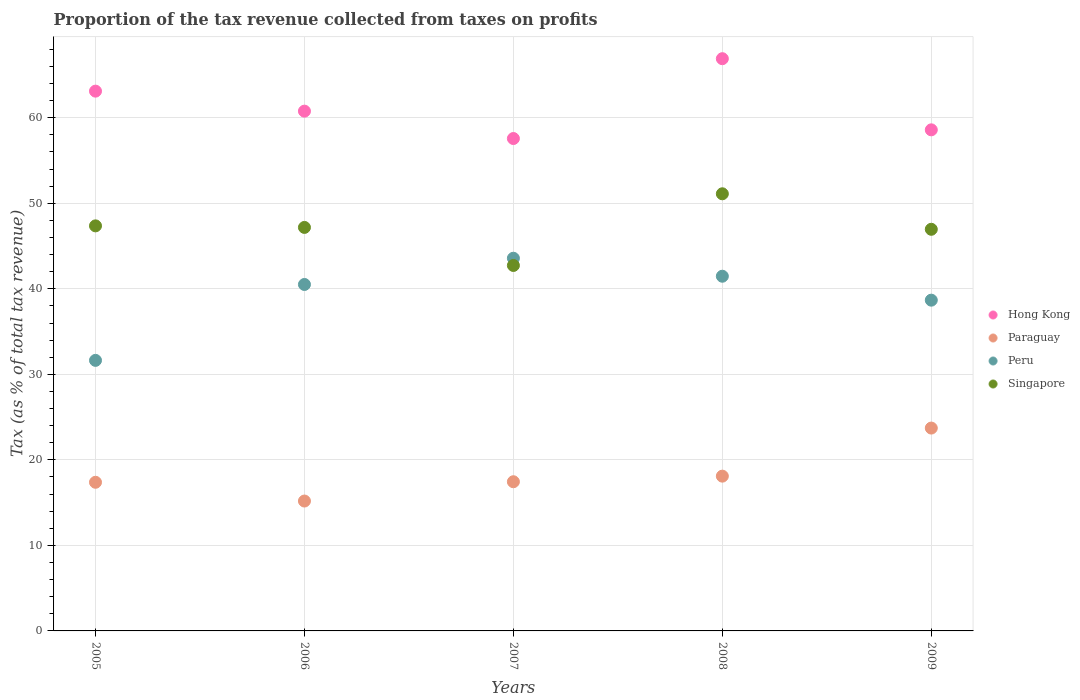How many different coloured dotlines are there?
Ensure brevity in your answer.  4. Is the number of dotlines equal to the number of legend labels?
Offer a very short reply. Yes. What is the proportion of the tax revenue collected in Peru in 2006?
Give a very brief answer. 40.5. Across all years, what is the maximum proportion of the tax revenue collected in Singapore?
Your answer should be very brief. 51.11. Across all years, what is the minimum proportion of the tax revenue collected in Singapore?
Provide a short and direct response. 42.73. In which year was the proportion of the tax revenue collected in Singapore maximum?
Your answer should be very brief. 2008. In which year was the proportion of the tax revenue collected in Peru minimum?
Ensure brevity in your answer.  2005. What is the total proportion of the tax revenue collected in Paraguay in the graph?
Your answer should be very brief. 91.82. What is the difference between the proportion of the tax revenue collected in Hong Kong in 2006 and that in 2007?
Give a very brief answer. 3.2. What is the difference between the proportion of the tax revenue collected in Paraguay in 2006 and the proportion of the tax revenue collected in Peru in 2007?
Your answer should be very brief. -28.39. What is the average proportion of the tax revenue collected in Hong Kong per year?
Your response must be concise. 61.39. In the year 2009, what is the difference between the proportion of the tax revenue collected in Paraguay and proportion of the tax revenue collected in Singapore?
Provide a succinct answer. -23.24. In how many years, is the proportion of the tax revenue collected in Singapore greater than 24 %?
Your response must be concise. 5. What is the ratio of the proportion of the tax revenue collected in Peru in 2005 to that in 2007?
Your answer should be very brief. 0.73. Is the proportion of the tax revenue collected in Paraguay in 2008 less than that in 2009?
Make the answer very short. Yes. Is the difference between the proportion of the tax revenue collected in Paraguay in 2008 and 2009 greater than the difference between the proportion of the tax revenue collected in Singapore in 2008 and 2009?
Keep it short and to the point. No. What is the difference between the highest and the second highest proportion of the tax revenue collected in Peru?
Provide a short and direct response. 2.1. What is the difference between the highest and the lowest proportion of the tax revenue collected in Paraguay?
Offer a terse response. 8.53. In how many years, is the proportion of the tax revenue collected in Peru greater than the average proportion of the tax revenue collected in Peru taken over all years?
Keep it short and to the point. 3. Is the sum of the proportion of the tax revenue collected in Paraguay in 2006 and 2009 greater than the maximum proportion of the tax revenue collected in Hong Kong across all years?
Make the answer very short. No. Is it the case that in every year, the sum of the proportion of the tax revenue collected in Peru and proportion of the tax revenue collected in Hong Kong  is greater than the proportion of the tax revenue collected in Paraguay?
Provide a succinct answer. Yes. Does the proportion of the tax revenue collected in Paraguay monotonically increase over the years?
Keep it short and to the point. No. How many dotlines are there?
Your answer should be very brief. 4. What is the difference between two consecutive major ticks on the Y-axis?
Make the answer very short. 10. Are the values on the major ticks of Y-axis written in scientific E-notation?
Offer a terse response. No. Where does the legend appear in the graph?
Your answer should be very brief. Center right. How are the legend labels stacked?
Make the answer very short. Vertical. What is the title of the graph?
Give a very brief answer. Proportion of the tax revenue collected from taxes on profits. What is the label or title of the X-axis?
Keep it short and to the point. Years. What is the label or title of the Y-axis?
Keep it short and to the point. Tax (as % of total tax revenue). What is the Tax (as % of total tax revenue) in Hong Kong in 2005?
Ensure brevity in your answer.  63.11. What is the Tax (as % of total tax revenue) in Paraguay in 2005?
Your response must be concise. 17.38. What is the Tax (as % of total tax revenue) of Peru in 2005?
Your response must be concise. 31.63. What is the Tax (as % of total tax revenue) of Singapore in 2005?
Your answer should be very brief. 47.36. What is the Tax (as % of total tax revenue) in Hong Kong in 2006?
Offer a terse response. 60.77. What is the Tax (as % of total tax revenue) of Paraguay in 2006?
Offer a terse response. 15.19. What is the Tax (as % of total tax revenue) of Peru in 2006?
Offer a very short reply. 40.5. What is the Tax (as % of total tax revenue) in Singapore in 2006?
Offer a very short reply. 47.18. What is the Tax (as % of total tax revenue) of Hong Kong in 2007?
Offer a very short reply. 57.57. What is the Tax (as % of total tax revenue) of Paraguay in 2007?
Give a very brief answer. 17.44. What is the Tax (as % of total tax revenue) in Peru in 2007?
Offer a terse response. 43.57. What is the Tax (as % of total tax revenue) in Singapore in 2007?
Provide a succinct answer. 42.73. What is the Tax (as % of total tax revenue) in Hong Kong in 2008?
Provide a succinct answer. 66.9. What is the Tax (as % of total tax revenue) of Paraguay in 2008?
Ensure brevity in your answer.  18.1. What is the Tax (as % of total tax revenue) of Peru in 2008?
Your response must be concise. 41.47. What is the Tax (as % of total tax revenue) of Singapore in 2008?
Provide a succinct answer. 51.11. What is the Tax (as % of total tax revenue) in Hong Kong in 2009?
Offer a very short reply. 58.59. What is the Tax (as % of total tax revenue) in Paraguay in 2009?
Offer a very short reply. 23.72. What is the Tax (as % of total tax revenue) in Peru in 2009?
Make the answer very short. 38.67. What is the Tax (as % of total tax revenue) in Singapore in 2009?
Ensure brevity in your answer.  46.96. Across all years, what is the maximum Tax (as % of total tax revenue) of Hong Kong?
Your answer should be compact. 66.9. Across all years, what is the maximum Tax (as % of total tax revenue) of Paraguay?
Offer a terse response. 23.72. Across all years, what is the maximum Tax (as % of total tax revenue) in Peru?
Ensure brevity in your answer.  43.57. Across all years, what is the maximum Tax (as % of total tax revenue) in Singapore?
Keep it short and to the point. 51.11. Across all years, what is the minimum Tax (as % of total tax revenue) of Hong Kong?
Offer a terse response. 57.57. Across all years, what is the minimum Tax (as % of total tax revenue) of Paraguay?
Your response must be concise. 15.19. Across all years, what is the minimum Tax (as % of total tax revenue) in Peru?
Provide a short and direct response. 31.63. Across all years, what is the minimum Tax (as % of total tax revenue) of Singapore?
Your response must be concise. 42.73. What is the total Tax (as % of total tax revenue) of Hong Kong in the graph?
Keep it short and to the point. 306.94. What is the total Tax (as % of total tax revenue) in Paraguay in the graph?
Your answer should be compact. 91.82. What is the total Tax (as % of total tax revenue) in Peru in the graph?
Ensure brevity in your answer.  195.85. What is the total Tax (as % of total tax revenue) in Singapore in the graph?
Your answer should be compact. 235.33. What is the difference between the Tax (as % of total tax revenue) of Hong Kong in 2005 and that in 2006?
Make the answer very short. 2.34. What is the difference between the Tax (as % of total tax revenue) in Paraguay in 2005 and that in 2006?
Ensure brevity in your answer.  2.19. What is the difference between the Tax (as % of total tax revenue) in Peru in 2005 and that in 2006?
Your response must be concise. -8.87. What is the difference between the Tax (as % of total tax revenue) in Singapore in 2005 and that in 2006?
Provide a succinct answer. 0.18. What is the difference between the Tax (as % of total tax revenue) of Hong Kong in 2005 and that in 2007?
Provide a short and direct response. 5.54. What is the difference between the Tax (as % of total tax revenue) of Paraguay in 2005 and that in 2007?
Offer a very short reply. -0.06. What is the difference between the Tax (as % of total tax revenue) in Peru in 2005 and that in 2007?
Offer a very short reply. -11.94. What is the difference between the Tax (as % of total tax revenue) of Singapore in 2005 and that in 2007?
Provide a short and direct response. 4.63. What is the difference between the Tax (as % of total tax revenue) in Hong Kong in 2005 and that in 2008?
Your answer should be compact. -3.79. What is the difference between the Tax (as % of total tax revenue) of Paraguay in 2005 and that in 2008?
Make the answer very short. -0.72. What is the difference between the Tax (as % of total tax revenue) of Peru in 2005 and that in 2008?
Offer a very short reply. -9.84. What is the difference between the Tax (as % of total tax revenue) in Singapore in 2005 and that in 2008?
Make the answer very short. -3.75. What is the difference between the Tax (as % of total tax revenue) in Hong Kong in 2005 and that in 2009?
Your answer should be very brief. 4.52. What is the difference between the Tax (as % of total tax revenue) of Paraguay in 2005 and that in 2009?
Keep it short and to the point. -6.34. What is the difference between the Tax (as % of total tax revenue) in Peru in 2005 and that in 2009?
Your answer should be compact. -7.04. What is the difference between the Tax (as % of total tax revenue) of Singapore in 2005 and that in 2009?
Your answer should be compact. 0.4. What is the difference between the Tax (as % of total tax revenue) in Hong Kong in 2006 and that in 2007?
Your response must be concise. 3.2. What is the difference between the Tax (as % of total tax revenue) in Paraguay in 2006 and that in 2007?
Your response must be concise. -2.26. What is the difference between the Tax (as % of total tax revenue) of Peru in 2006 and that in 2007?
Ensure brevity in your answer.  -3.07. What is the difference between the Tax (as % of total tax revenue) of Singapore in 2006 and that in 2007?
Keep it short and to the point. 4.45. What is the difference between the Tax (as % of total tax revenue) in Hong Kong in 2006 and that in 2008?
Your response must be concise. -6.13. What is the difference between the Tax (as % of total tax revenue) of Paraguay in 2006 and that in 2008?
Your answer should be very brief. -2.91. What is the difference between the Tax (as % of total tax revenue) in Peru in 2006 and that in 2008?
Offer a very short reply. -0.96. What is the difference between the Tax (as % of total tax revenue) of Singapore in 2006 and that in 2008?
Offer a terse response. -3.93. What is the difference between the Tax (as % of total tax revenue) in Hong Kong in 2006 and that in 2009?
Ensure brevity in your answer.  2.18. What is the difference between the Tax (as % of total tax revenue) in Paraguay in 2006 and that in 2009?
Make the answer very short. -8.53. What is the difference between the Tax (as % of total tax revenue) in Peru in 2006 and that in 2009?
Give a very brief answer. 1.83. What is the difference between the Tax (as % of total tax revenue) in Singapore in 2006 and that in 2009?
Your answer should be compact. 0.22. What is the difference between the Tax (as % of total tax revenue) in Hong Kong in 2007 and that in 2008?
Keep it short and to the point. -9.33. What is the difference between the Tax (as % of total tax revenue) in Paraguay in 2007 and that in 2008?
Your answer should be very brief. -0.65. What is the difference between the Tax (as % of total tax revenue) in Peru in 2007 and that in 2008?
Ensure brevity in your answer.  2.1. What is the difference between the Tax (as % of total tax revenue) of Singapore in 2007 and that in 2008?
Offer a terse response. -8.38. What is the difference between the Tax (as % of total tax revenue) in Hong Kong in 2007 and that in 2009?
Provide a succinct answer. -1.02. What is the difference between the Tax (as % of total tax revenue) in Paraguay in 2007 and that in 2009?
Ensure brevity in your answer.  -6.28. What is the difference between the Tax (as % of total tax revenue) of Peru in 2007 and that in 2009?
Your response must be concise. 4.9. What is the difference between the Tax (as % of total tax revenue) in Singapore in 2007 and that in 2009?
Your response must be concise. -4.23. What is the difference between the Tax (as % of total tax revenue) in Hong Kong in 2008 and that in 2009?
Ensure brevity in your answer.  8.32. What is the difference between the Tax (as % of total tax revenue) in Paraguay in 2008 and that in 2009?
Offer a very short reply. -5.62. What is the difference between the Tax (as % of total tax revenue) in Peru in 2008 and that in 2009?
Provide a short and direct response. 2.8. What is the difference between the Tax (as % of total tax revenue) of Singapore in 2008 and that in 2009?
Give a very brief answer. 4.15. What is the difference between the Tax (as % of total tax revenue) of Hong Kong in 2005 and the Tax (as % of total tax revenue) of Paraguay in 2006?
Your answer should be very brief. 47.92. What is the difference between the Tax (as % of total tax revenue) of Hong Kong in 2005 and the Tax (as % of total tax revenue) of Peru in 2006?
Your answer should be compact. 22.6. What is the difference between the Tax (as % of total tax revenue) in Hong Kong in 2005 and the Tax (as % of total tax revenue) in Singapore in 2006?
Provide a short and direct response. 15.93. What is the difference between the Tax (as % of total tax revenue) in Paraguay in 2005 and the Tax (as % of total tax revenue) in Peru in 2006?
Provide a short and direct response. -23.13. What is the difference between the Tax (as % of total tax revenue) of Paraguay in 2005 and the Tax (as % of total tax revenue) of Singapore in 2006?
Offer a very short reply. -29.8. What is the difference between the Tax (as % of total tax revenue) of Peru in 2005 and the Tax (as % of total tax revenue) of Singapore in 2006?
Your response must be concise. -15.54. What is the difference between the Tax (as % of total tax revenue) in Hong Kong in 2005 and the Tax (as % of total tax revenue) in Paraguay in 2007?
Keep it short and to the point. 45.67. What is the difference between the Tax (as % of total tax revenue) in Hong Kong in 2005 and the Tax (as % of total tax revenue) in Peru in 2007?
Provide a short and direct response. 19.54. What is the difference between the Tax (as % of total tax revenue) of Hong Kong in 2005 and the Tax (as % of total tax revenue) of Singapore in 2007?
Provide a succinct answer. 20.38. What is the difference between the Tax (as % of total tax revenue) of Paraguay in 2005 and the Tax (as % of total tax revenue) of Peru in 2007?
Give a very brief answer. -26.19. What is the difference between the Tax (as % of total tax revenue) in Paraguay in 2005 and the Tax (as % of total tax revenue) in Singapore in 2007?
Your answer should be very brief. -25.35. What is the difference between the Tax (as % of total tax revenue) in Peru in 2005 and the Tax (as % of total tax revenue) in Singapore in 2007?
Offer a terse response. -11.1. What is the difference between the Tax (as % of total tax revenue) of Hong Kong in 2005 and the Tax (as % of total tax revenue) of Paraguay in 2008?
Your answer should be very brief. 45.01. What is the difference between the Tax (as % of total tax revenue) in Hong Kong in 2005 and the Tax (as % of total tax revenue) in Peru in 2008?
Make the answer very short. 21.64. What is the difference between the Tax (as % of total tax revenue) in Hong Kong in 2005 and the Tax (as % of total tax revenue) in Singapore in 2008?
Provide a succinct answer. 12. What is the difference between the Tax (as % of total tax revenue) of Paraguay in 2005 and the Tax (as % of total tax revenue) of Peru in 2008?
Keep it short and to the point. -24.09. What is the difference between the Tax (as % of total tax revenue) in Paraguay in 2005 and the Tax (as % of total tax revenue) in Singapore in 2008?
Make the answer very short. -33.73. What is the difference between the Tax (as % of total tax revenue) of Peru in 2005 and the Tax (as % of total tax revenue) of Singapore in 2008?
Your answer should be compact. -19.48. What is the difference between the Tax (as % of total tax revenue) of Hong Kong in 2005 and the Tax (as % of total tax revenue) of Paraguay in 2009?
Provide a succinct answer. 39.39. What is the difference between the Tax (as % of total tax revenue) in Hong Kong in 2005 and the Tax (as % of total tax revenue) in Peru in 2009?
Make the answer very short. 24.44. What is the difference between the Tax (as % of total tax revenue) of Hong Kong in 2005 and the Tax (as % of total tax revenue) of Singapore in 2009?
Keep it short and to the point. 16.15. What is the difference between the Tax (as % of total tax revenue) in Paraguay in 2005 and the Tax (as % of total tax revenue) in Peru in 2009?
Provide a succinct answer. -21.29. What is the difference between the Tax (as % of total tax revenue) in Paraguay in 2005 and the Tax (as % of total tax revenue) in Singapore in 2009?
Ensure brevity in your answer.  -29.58. What is the difference between the Tax (as % of total tax revenue) in Peru in 2005 and the Tax (as % of total tax revenue) in Singapore in 2009?
Provide a succinct answer. -15.33. What is the difference between the Tax (as % of total tax revenue) of Hong Kong in 2006 and the Tax (as % of total tax revenue) of Paraguay in 2007?
Provide a short and direct response. 43.33. What is the difference between the Tax (as % of total tax revenue) in Hong Kong in 2006 and the Tax (as % of total tax revenue) in Peru in 2007?
Give a very brief answer. 17.2. What is the difference between the Tax (as % of total tax revenue) in Hong Kong in 2006 and the Tax (as % of total tax revenue) in Singapore in 2007?
Give a very brief answer. 18.04. What is the difference between the Tax (as % of total tax revenue) in Paraguay in 2006 and the Tax (as % of total tax revenue) in Peru in 2007?
Provide a short and direct response. -28.39. What is the difference between the Tax (as % of total tax revenue) in Paraguay in 2006 and the Tax (as % of total tax revenue) in Singapore in 2007?
Make the answer very short. -27.54. What is the difference between the Tax (as % of total tax revenue) of Peru in 2006 and the Tax (as % of total tax revenue) of Singapore in 2007?
Keep it short and to the point. -2.22. What is the difference between the Tax (as % of total tax revenue) in Hong Kong in 2006 and the Tax (as % of total tax revenue) in Paraguay in 2008?
Your answer should be very brief. 42.67. What is the difference between the Tax (as % of total tax revenue) of Hong Kong in 2006 and the Tax (as % of total tax revenue) of Peru in 2008?
Keep it short and to the point. 19.3. What is the difference between the Tax (as % of total tax revenue) in Hong Kong in 2006 and the Tax (as % of total tax revenue) in Singapore in 2008?
Provide a short and direct response. 9.66. What is the difference between the Tax (as % of total tax revenue) in Paraguay in 2006 and the Tax (as % of total tax revenue) in Peru in 2008?
Your response must be concise. -26.28. What is the difference between the Tax (as % of total tax revenue) in Paraguay in 2006 and the Tax (as % of total tax revenue) in Singapore in 2008?
Make the answer very short. -35.92. What is the difference between the Tax (as % of total tax revenue) of Peru in 2006 and the Tax (as % of total tax revenue) of Singapore in 2008?
Make the answer very short. -10.6. What is the difference between the Tax (as % of total tax revenue) in Hong Kong in 2006 and the Tax (as % of total tax revenue) in Paraguay in 2009?
Provide a short and direct response. 37.05. What is the difference between the Tax (as % of total tax revenue) in Hong Kong in 2006 and the Tax (as % of total tax revenue) in Peru in 2009?
Offer a terse response. 22.1. What is the difference between the Tax (as % of total tax revenue) in Hong Kong in 2006 and the Tax (as % of total tax revenue) in Singapore in 2009?
Offer a terse response. 13.81. What is the difference between the Tax (as % of total tax revenue) of Paraguay in 2006 and the Tax (as % of total tax revenue) of Peru in 2009?
Provide a succinct answer. -23.49. What is the difference between the Tax (as % of total tax revenue) of Paraguay in 2006 and the Tax (as % of total tax revenue) of Singapore in 2009?
Your response must be concise. -31.77. What is the difference between the Tax (as % of total tax revenue) in Peru in 2006 and the Tax (as % of total tax revenue) in Singapore in 2009?
Give a very brief answer. -6.45. What is the difference between the Tax (as % of total tax revenue) of Hong Kong in 2007 and the Tax (as % of total tax revenue) of Paraguay in 2008?
Make the answer very short. 39.47. What is the difference between the Tax (as % of total tax revenue) of Hong Kong in 2007 and the Tax (as % of total tax revenue) of Peru in 2008?
Ensure brevity in your answer.  16.1. What is the difference between the Tax (as % of total tax revenue) in Hong Kong in 2007 and the Tax (as % of total tax revenue) in Singapore in 2008?
Your answer should be compact. 6.46. What is the difference between the Tax (as % of total tax revenue) in Paraguay in 2007 and the Tax (as % of total tax revenue) in Peru in 2008?
Your response must be concise. -24.03. What is the difference between the Tax (as % of total tax revenue) in Paraguay in 2007 and the Tax (as % of total tax revenue) in Singapore in 2008?
Keep it short and to the point. -33.67. What is the difference between the Tax (as % of total tax revenue) in Peru in 2007 and the Tax (as % of total tax revenue) in Singapore in 2008?
Your answer should be very brief. -7.53. What is the difference between the Tax (as % of total tax revenue) of Hong Kong in 2007 and the Tax (as % of total tax revenue) of Paraguay in 2009?
Your response must be concise. 33.85. What is the difference between the Tax (as % of total tax revenue) in Hong Kong in 2007 and the Tax (as % of total tax revenue) in Peru in 2009?
Your response must be concise. 18.9. What is the difference between the Tax (as % of total tax revenue) in Hong Kong in 2007 and the Tax (as % of total tax revenue) in Singapore in 2009?
Provide a succinct answer. 10.61. What is the difference between the Tax (as % of total tax revenue) in Paraguay in 2007 and the Tax (as % of total tax revenue) in Peru in 2009?
Your response must be concise. -21.23. What is the difference between the Tax (as % of total tax revenue) of Paraguay in 2007 and the Tax (as % of total tax revenue) of Singapore in 2009?
Offer a terse response. -29.52. What is the difference between the Tax (as % of total tax revenue) in Peru in 2007 and the Tax (as % of total tax revenue) in Singapore in 2009?
Make the answer very short. -3.38. What is the difference between the Tax (as % of total tax revenue) of Hong Kong in 2008 and the Tax (as % of total tax revenue) of Paraguay in 2009?
Your response must be concise. 43.19. What is the difference between the Tax (as % of total tax revenue) of Hong Kong in 2008 and the Tax (as % of total tax revenue) of Peru in 2009?
Offer a very short reply. 28.23. What is the difference between the Tax (as % of total tax revenue) of Hong Kong in 2008 and the Tax (as % of total tax revenue) of Singapore in 2009?
Keep it short and to the point. 19.95. What is the difference between the Tax (as % of total tax revenue) in Paraguay in 2008 and the Tax (as % of total tax revenue) in Peru in 2009?
Provide a short and direct response. -20.57. What is the difference between the Tax (as % of total tax revenue) of Paraguay in 2008 and the Tax (as % of total tax revenue) of Singapore in 2009?
Give a very brief answer. -28.86. What is the difference between the Tax (as % of total tax revenue) in Peru in 2008 and the Tax (as % of total tax revenue) in Singapore in 2009?
Give a very brief answer. -5.49. What is the average Tax (as % of total tax revenue) of Hong Kong per year?
Offer a terse response. 61.39. What is the average Tax (as % of total tax revenue) in Paraguay per year?
Provide a succinct answer. 18.36. What is the average Tax (as % of total tax revenue) of Peru per year?
Ensure brevity in your answer.  39.17. What is the average Tax (as % of total tax revenue) in Singapore per year?
Your answer should be very brief. 47.07. In the year 2005, what is the difference between the Tax (as % of total tax revenue) of Hong Kong and Tax (as % of total tax revenue) of Paraguay?
Give a very brief answer. 45.73. In the year 2005, what is the difference between the Tax (as % of total tax revenue) in Hong Kong and Tax (as % of total tax revenue) in Peru?
Give a very brief answer. 31.48. In the year 2005, what is the difference between the Tax (as % of total tax revenue) in Hong Kong and Tax (as % of total tax revenue) in Singapore?
Ensure brevity in your answer.  15.75. In the year 2005, what is the difference between the Tax (as % of total tax revenue) of Paraguay and Tax (as % of total tax revenue) of Peru?
Provide a succinct answer. -14.25. In the year 2005, what is the difference between the Tax (as % of total tax revenue) in Paraguay and Tax (as % of total tax revenue) in Singapore?
Your response must be concise. -29.98. In the year 2005, what is the difference between the Tax (as % of total tax revenue) in Peru and Tax (as % of total tax revenue) in Singapore?
Offer a very short reply. -15.73. In the year 2006, what is the difference between the Tax (as % of total tax revenue) in Hong Kong and Tax (as % of total tax revenue) in Paraguay?
Your response must be concise. 45.58. In the year 2006, what is the difference between the Tax (as % of total tax revenue) of Hong Kong and Tax (as % of total tax revenue) of Peru?
Make the answer very short. 20.27. In the year 2006, what is the difference between the Tax (as % of total tax revenue) in Hong Kong and Tax (as % of total tax revenue) in Singapore?
Give a very brief answer. 13.59. In the year 2006, what is the difference between the Tax (as % of total tax revenue) of Paraguay and Tax (as % of total tax revenue) of Peru?
Provide a succinct answer. -25.32. In the year 2006, what is the difference between the Tax (as % of total tax revenue) in Paraguay and Tax (as % of total tax revenue) in Singapore?
Make the answer very short. -31.99. In the year 2006, what is the difference between the Tax (as % of total tax revenue) of Peru and Tax (as % of total tax revenue) of Singapore?
Offer a very short reply. -6.67. In the year 2007, what is the difference between the Tax (as % of total tax revenue) of Hong Kong and Tax (as % of total tax revenue) of Paraguay?
Ensure brevity in your answer.  40.13. In the year 2007, what is the difference between the Tax (as % of total tax revenue) of Hong Kong and Tax (as % of total tax revenue) of Peru?
Your response must be concise. 14. In the year 2007, what is the difference between the Tax (as % of total tax revenue) of Hong Kong and Tax (as % of total tax revenue) of Singapore?
Give a very brief answer. 14.84. In the year 2007, what is the difference between the Tax (as % of total tax revenue) in Paraguay and Tax (as % of total tax revenue) in Peru?
Make the answer very short. -26.13. In the year 2007, what is the difference between the Tax (as % of total tax revenue) in Paraguay and Tax (as % of total tax revenue) in Singapore?
Provide a succinct answer. -25.29. In the year 2007, what is the difference between the Tax (as % of total tax revenue) in Peru and Tax (as % of total tax revenue) in Singapore?
Keep it short and to the point. 0.85. In the year 2008, what is the difference between the Tax (as % of total tax revenue) in Hong Kong and Tax (as % of total tax revenue) in Paraguay?
Ensure brevity in your answer.  48.81. In the year 2008, what is the difference between the Tax (as % of total tax revenue) of Hong Kong and Tax (as % of total tax revenue) of Peru?
Ensure brevity in your answer.  25.43. In the year 2008, what is the difference between the Tax (as % of total tax revenue) in Hong Kong and Tax (as % of total tax revenue) in Singapore?
Offer a terse response. 15.8. In the year 2008, what is the difference between the Tax (as % of total tax revenue) of Paraguay and Tax (as % of total tax revenue) of Peru?
Your answer should be compact. -23.37. In the year 2008, what is the difference between the Tax (as % of total tax revenue) of Paraguay and Tax (as % of total tax revenue) of Singapore?
Your answer should be compact. -33.01. In the year 2008, what is the difference between the Tax (as % of total tax revenue) in Peru and Tax (as % of total tax revenue) in Singapore?
Your response must be concise. -9.64. In the year 2009, what is the difference between the Tax (as % of total tax revenue) in Hong Kong and Tax (as % of total tax revenue) in Paraguay?
Offer a terse response. 34.87. In the year 2009, what is the difference between the Tax (as % of total tax revenue) in Hong Kong and Tax (as % of total tax revenue) in Peru?
Ensure brevity in your answer.  19.91. In the year 2009, what is the difference between the Tax (as % of total tax revenue) in Hong Kong and Tax (as % of total tax revenue) in Singapore?
Provide a short and direct response. 11.63. In the year 2009, what is the difference between the Tax (as % of total tax revenue) of Paraguay and Tax (as % of total tax revenue) of Peru?
Give a very brief answer. -14.95. In the year 2009, what is the difference between the Tax (as % of total tax revenue) in Paraguay and Tax (as % of total tax revenue) in Singapore?
Ensure brevity in your answer.  -23.24. In the year 2009, what is the difference between the Tax (as % of total tax revenue) in Peru and Tax (as % of total tax revenue) in Singapore?
Your answer should be very brief. -8.29. What is the ratio of the Tax (as % of total tax revenue) of Hong Kong in 2005 to that in 2006?
Your answer should be very brief. 1.04. What is the ratio of the Tax (as % of total tax revenue) of Paraguay in 2005 to that in 2006?
Give a very brief answer. 1.14. What is the ratio of the Tax (as % of total tax revenue) in Peru in 2005 to that in 2006?
Provide a short and direct response. 0.78. What is the ratio of the Tax (as % of total tax revenue) of Singapore in 2005 to that in 2006?
Give a very brief answer. 1. What is the ratio of the Tax (as % of total tax revenue) of Hong Kong in 2005 to that in 2007?
Give a very brief answer. 1.1. What is the ratio of the Tax (as % of total tax revenue) in Peru in 2005 to that in 2007?
Your answer should be very brief. 0.73. What is the ratio of the Tax (as % of total tax revenue) in Singapore in 2005 to that in 2007?
Your answer should be very brief. 1.11. What is the ratio of the Tax (as % of total tax revenue) in Hong Kong in 2005 to that in 2008?
Offer a very short reply. 0.94. What is the ratio of the Tax (as % of total tax revenue) in Paraguay in 2005 to that in 2008?
Make the answer very short. 0.96. What is the ratio of the Tax (as % of total tax revenue) in Peru in 2005 to that in 2008?
Your answer should be compact. 0.76. What is the ratio of the Tax (as % of total tax revenue) in Singapore in 2005 to that in 2008?
Give a very brief answer. 0.93. What is the ratio of the Tax (as % of total tax revenue) in Hong Kong in 2005 to that in 2009?
Provide a succinct answer. 1.08. What is the ratio of the Tax (as % of total tax revenue) in Paraguay in 2005 to that in 2009?
Keep it short and to the point. 0.73. What is the ratio of the Tax (as % of total tax revenue) in Peru in 2005 to that in 2009?
Offer a very short reply. 0.82. What is the ratio of the Tax (as % of total tax revenue) of Singapore in 2005 to that in 2009?
Provide a succinct answer. 1.01. What is the ratio of the Tax (as % of total tax revenue) in Hong Kong in 2006 to that in 2007?
Give a very brief answer. 1.06. What is the ratio of the Tax (as % of total tax revenue) of Paraguay in 2006 to that in 2007?
Keep it short and to the point. 0.87. What is the ratio of the Tax (as % of total tax revenue) of Peru in 2006 to that in 2007?
Offer a very short reply. 0.93. What is the ratio of the Tax (as % of total tax revenue) in Singapore in 2006 to that in 2007?
Give a very brief answer. 1.1. What is the ratio of the Tax (as % of total tax revenue) in Hong Kong in 2006 to that in 2008?
Provide a succinct answer. 0.91. What is the ratio of the Tax (as % of total tax revenue) in Paraguay in 2006 to that in 2008?
Give a very brief answer. 0.84. What is the ratio of the Tax (as % of total tax revenue) in Peru in 2006 to that in 2008?
Offer a very short reply. 0.98. What is the ratio of the Tax (as % of total tax revenue) in Singapore in 2006 to that in 2008?
Ensure brevity in your answer.  0.92. What is the ratio of the Tax (as % of total tax revenue) in Hong Kong in 2006 to that in 2009?
Your answer should be compact. 1.04. What is the ratio of the Tax (as % of total tax revenue) in Paraguay in 2006 to that in 2009?
Your answer should be very brief. 0.64. What is the ratio of the Tax (as % of total tax revenue) in Peru in 2006 to that in 2009?
Offer a terse response. 1.05. What is the ratio of the Tax (as % of total tax revenue) of Hong Kong in 2007 to that in 2008?
Offer a very short reply. 0.86. What is the ratio of the Tax (as % of total tax revenue) in Paraguay in 2007 to that in 2008?
Make the answer very short. 0.96. What is the ratio of the Tax (as % of total tax revenue) in Peru in 2007 to that in 2008?
Provide a succinct answer. 1.05. What is the ratio of the Tax (as % of total tax revenue) of Singapore in 2007 to that in 2008?
Provide a short and direct response. 0.84. What is the ratio of the Tax (as % of total tax revenue) in Hong Kong in 2007 to that in 2009?
Offer a terse response. 0.98. What is the ratio of the Tax (as % of total tax revenue) in Paraguay in 2007 to that in 2009?
Your response must be concise. 0.74. What is the ratio of the Tax (as % of total tax revenue) in Peru in 2007 to that in 2009?
Your response must be concise. 1.13. What is the ratio of the Tax (as % of total tax revenue) in Singapore in 2007 to that in 2009?
Make the answer very short. 0.91. What is the ratio of the Tax (as % of total tax revenue) in Hong Kong in 2008 to that in 2009?
Offer a terse response. 1.14. What is the ratio of the Tax (as % of total tax revenue) in Paraguay in 2008 to that in 2009?
Your answer should be compact. 0.76. What is the ratio of the Tax (as % of total tax revenue) of Peru in 2008 to that in 2009?
Give a very brief answer. 1.07. What is the ratio of the Tax (as % of total tax revenue) of Singapore in 2008 to that in 2009?
Offer a terse response. 1.09. What is the difference between the highest and the second highest Tax (as % of total tax revenue) of Hong Kong?
Your response must be concise. 3.79. What is the difference between the highest and the second highest Tax (as % of total tax revenue) of Paraguay?
Make the answer very short. 5.62. What is the difference between the highest and the second highest Tax (as % of total tax revenue) of Peru?
Offer a very short reply. 2.1. What is the difference between the highest and the second highest Tax (as % of total tax revenue) in Singapore?
Provide a succinct answer. 3.75. What is the difference between the highest and the lowest Tax (as % of total tax revenue) of Hong Kong?
Make the answer very short. 9.33. What is the difference between the highest and the lowest Tax (as % of total tax revenue) of Paraguay?
Make the answer very short. 8.53. What is the difference between the highest and the lowest Tax (as % of total tax revenue) of Peru?
Your answer should be compact. 11.94. What is the difference between the highest and the lowest Tax (as % of total tax revenue) of Singapore?
Offer a very short reply. 8.38. 